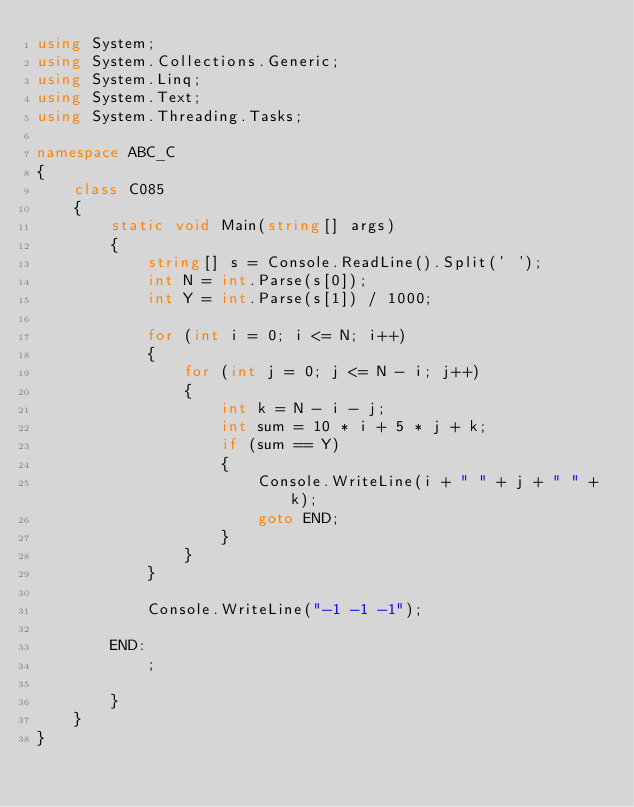Convert code to text. <code><loc_0><loc_0><loc_500><loc_500><_C#_>using System;
using System.Collections.Generic;
using System.Linq;
using System.Text;
using System.Threading.Tasks;

namespace ABC_C
{
    class C085
    {
        static void Main(string[] args)
        {
            string[] s = Console.ReadLine().Split(' ');
            int N = int.Parse(s[0]);
            int Y = int.Parse(s[1]) / 1000;

            for (int i = 0; i <= N; i++)
            {
                for (int j = 0; j <= N - i; j++)
                {
                    int k = N - i - j;
                    int sum = 10 * i + 5 * j + k;
                    if (sum == Y)
                    {
                        Console.WriteLine(i + " " + j + " " + k);
                        goto END;
                    }
                }
            }

            Console.WriteLine("-1 -1 -1");

        END:
            ;

        }
    }
}
</code> 